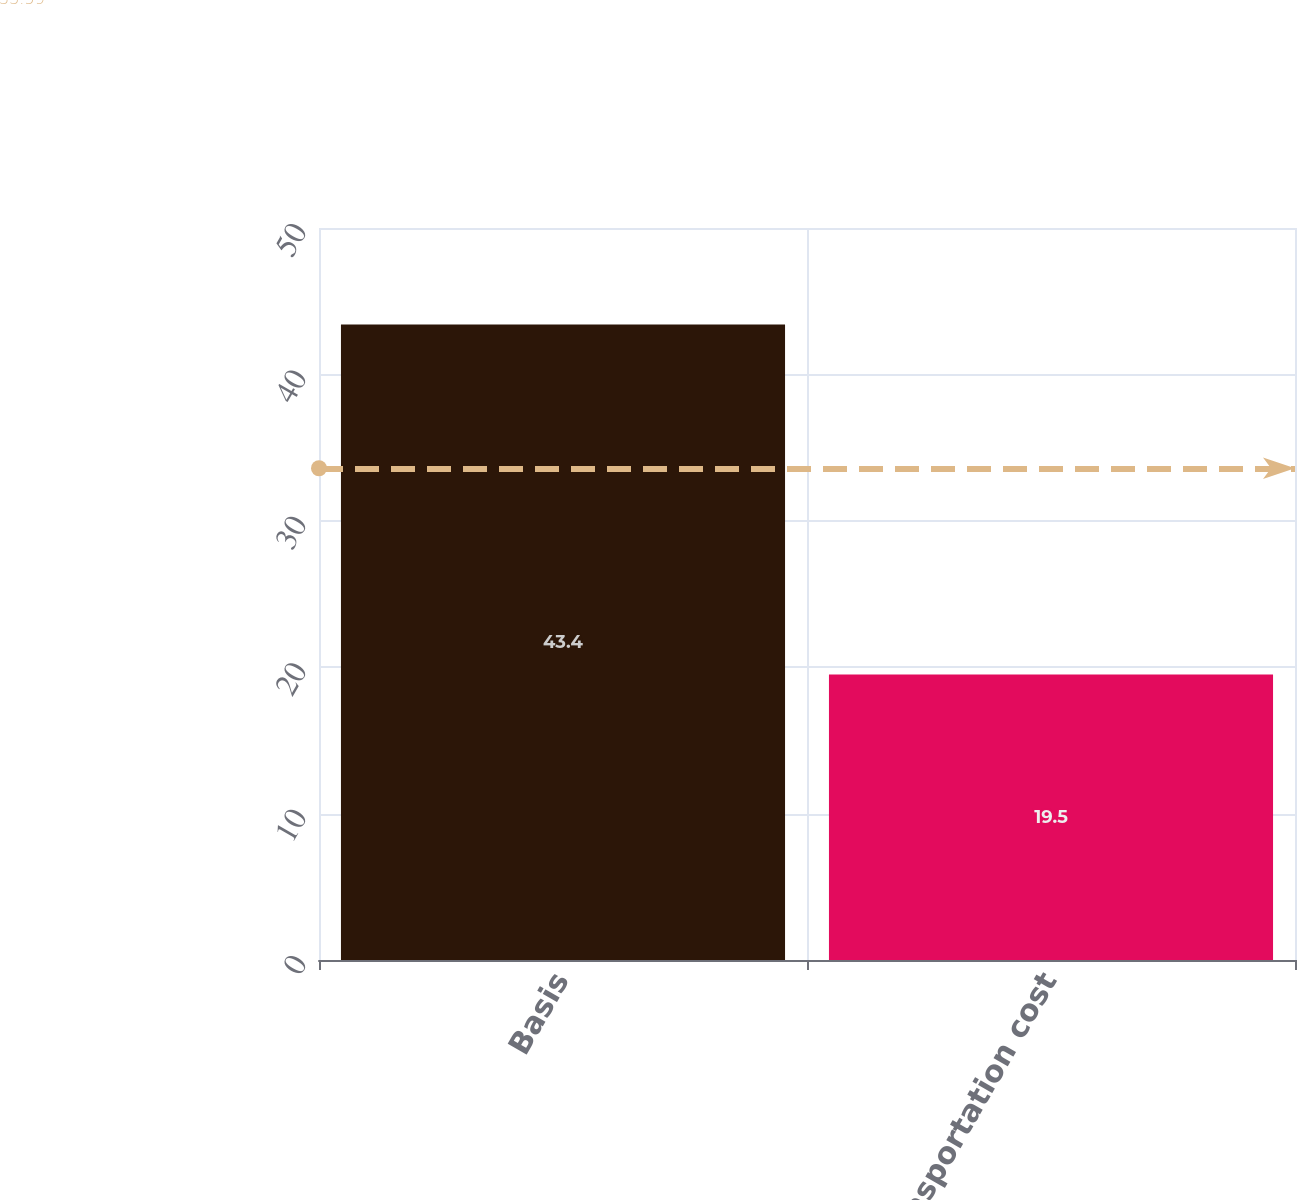Convert chart to OTSL. <chart><loc_0><loc_0><loc_500><loc_500><bar_chart><fcel>Basis<fcel>Transportation cost<nl><fcel>43.4<fcel>19.5<nl></chart> 